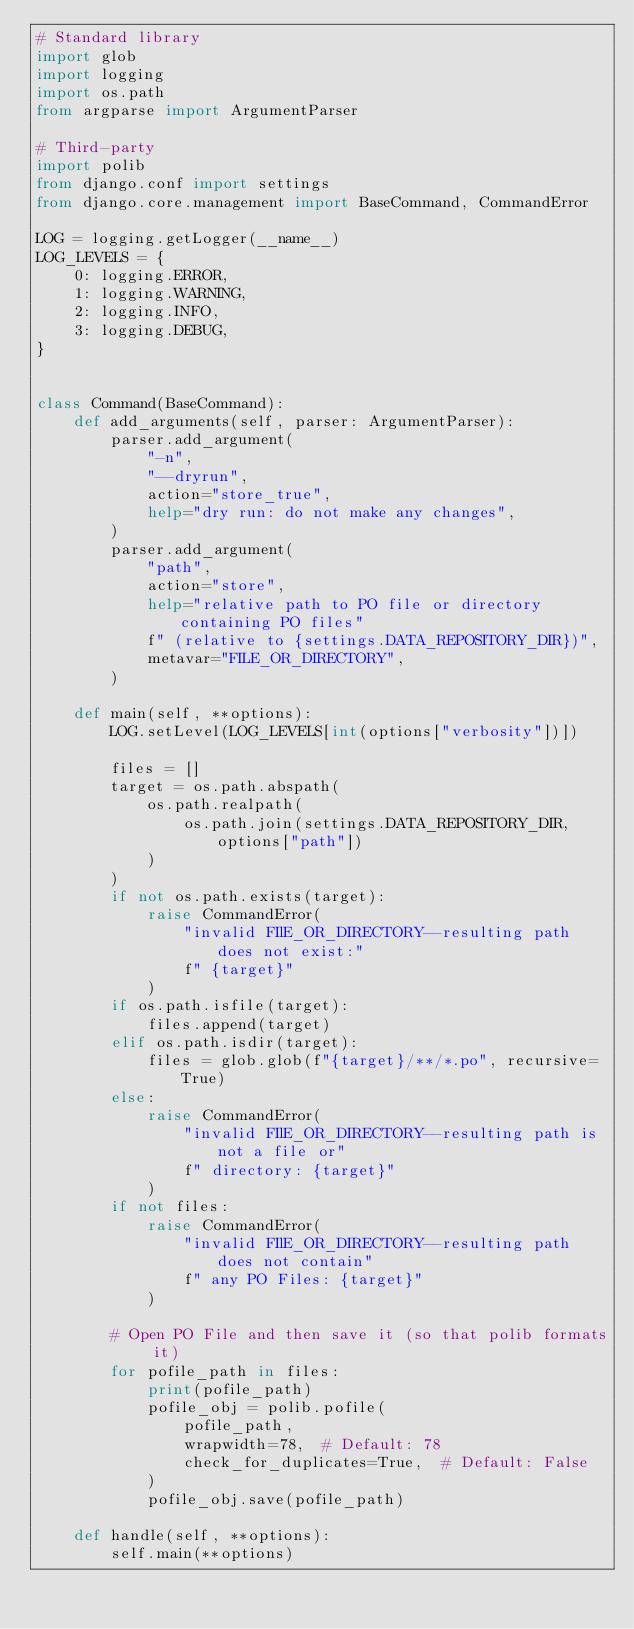Convert code to text. <code><loc_0><loc_0><loc_500><loc_500><_Python_># Standard library
import glob
import logging
import os.path
from argparse import ArgumentParser

# Third-party
import polib
from django.conf import settings
from django.core.management import BaseCommand, CommandError

LOG = logging.getLogger(__name__)
LOG_LEVELS = {
    0: logging.ERROR,
    1: logging.WARNING,
    2: logging.INFO,
    3: logging.DEBUG,
}


class Command(BaseCommand):
    def add_arguments(self, parser: ArgumentParser):
        parser.add_argument(
            "-n",
            "--dryrun",
            action="store_true",
            help="dry run: do not make any changes",
        )
        parser.add_argument(
            "path",
            action="store",
            help="relative path to PO file or directory containing PO files"
            f" (relative to {settings.DATA_REPOSITORY_DIR})",
            metavar="FILE_OR_DIRECTORY",
        )

    def main(self, **options):
        LOG.setLevel(LOG_LEVELS[int(options["verbosity"])])

        files = []
        target = os.path.abspath(
            os.path.realpath(
                os.path.join(settings.DATA_REPOSITORY_DIR, options["path"])
            )
        )
        if not os.path.exists(target):
            raise CommandError(
                "invalid FIlE_OR_DIRECTORY--resulting path does not exist:"
                f" {target}"
            )
        if os.path.isfile(target):
            files.append(target)
        elif os.path.isdir(target):
            files = glob.glob(f"{target}/**/*.po", recursive=True)
        else:
            raise CommandError(
                "invalid FIlE_OR_DIRECTORY--resulting path is not a file or"
                f" directory: {target}"
            )
        if not files:
            raise CommandError(
                "invalid FIlE_OR_DIRECTORY--resulting path does not contain"
                f" any PO Files: {target}"
            )

        # Open PO File and then save it (so that polib formats it)
        for pofile_path in files:
            print(pofile_path)
            pofile_obj = polib.pofile(
                pofile_path,
                wrapwidth=78,  # Default: 78
                check_for_duplicates=True,  # Default: False
            )
            pofile_obj.save(pofile_path)

    def handle(self, **options):
        self.main(**options)
</code> 